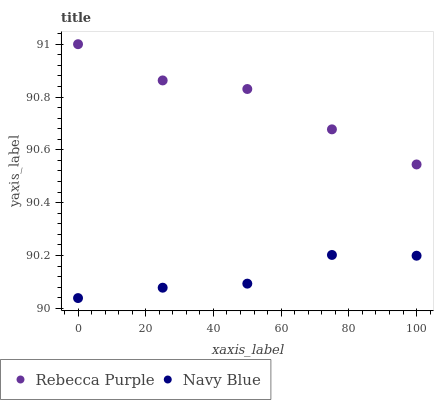Does Navy Blue have the minimum area under the curve?
Answer yes or no. Yes. Does Rebecca Purple have the maximum area under the curve?
Answer yes or no. Yes. Does Rebecca Purple have the minimum area under the curve?
Answer yes or no. No. Is Navy Blue the smoothest?
Answer yes or no. Yes. Is Rebecca Purple the roughest?
Answer yes or no. Yes. Is Rebecca Purple the smoothest?
Answer yes or no. No. Does Navy Blue have the lowest value?
Answer yes or no. Yes. Does Rebecca Purple have the lowest value?
Answer yes or no. No. Does Rebecca Purple have the highest value?
Answer yes or no. Yes. Is Navy Blue less than Rebecca Purple?
Answer yes or no. Yes. Is Rebecca Purple greater than Navy Blue?
Answer yes or no. Yes. Does Navy Blue intersect Rebecca Purple?
Answer yes or no. No. 